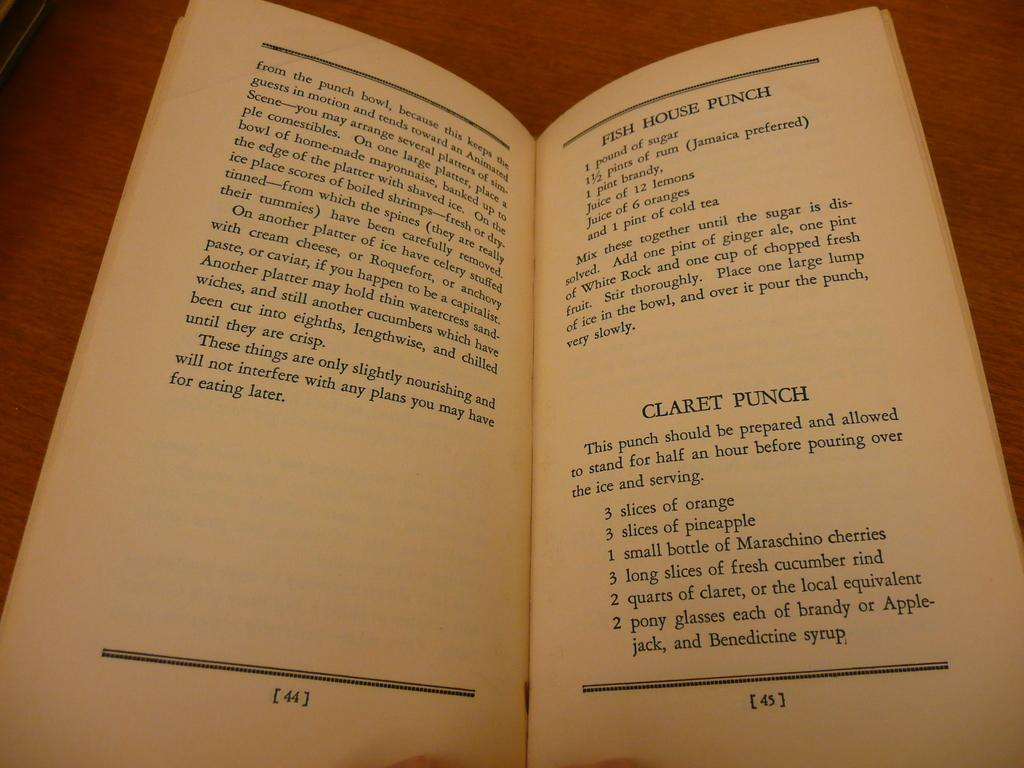<image>
Render a clear and concise summary of the photo. page 45 of an open book that says 'claret punch' on it in bold 